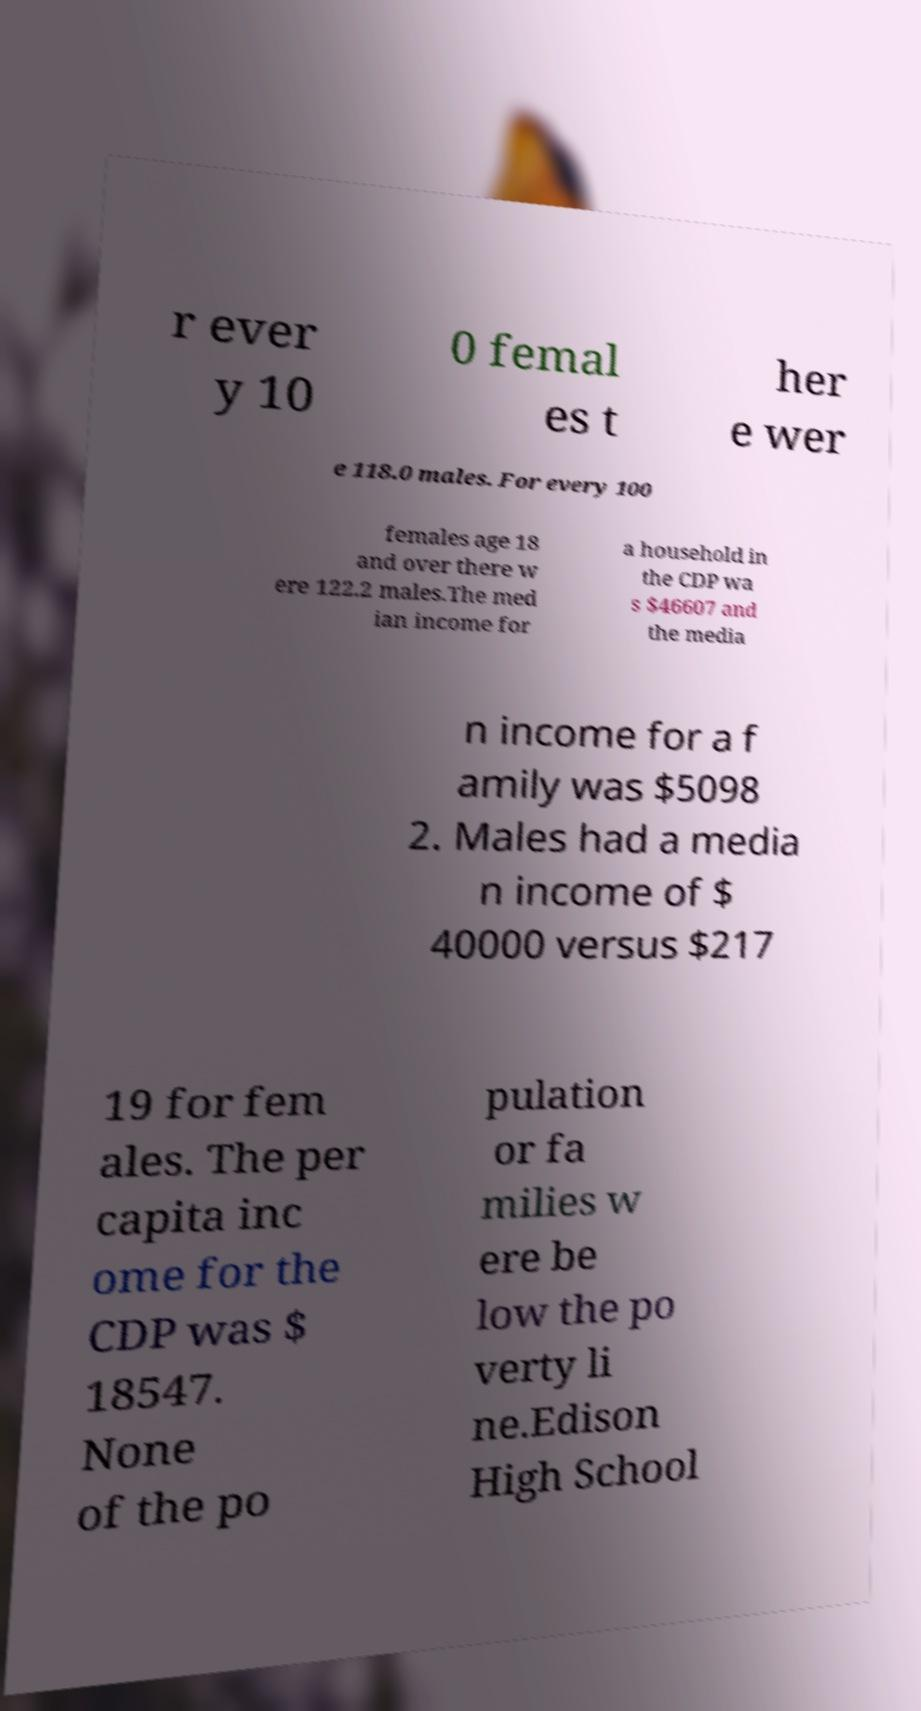Could you extract and type out the text from this image? r ever y 10 0 femal es t her e wer e 118.0 males. For every 100 females age 18 and over there w ere 122.2 males.The med ian income for a household in the CDP wa s $46607 and the media n income for a f amily was $5098 2. Males had a media n income of $ 40000 versus $217 19 for fem ales. The per capita inc ome for the CDP was $ 18547. None of the po pulation or fa milies w ere be low the po verty li ne.Edison High School 